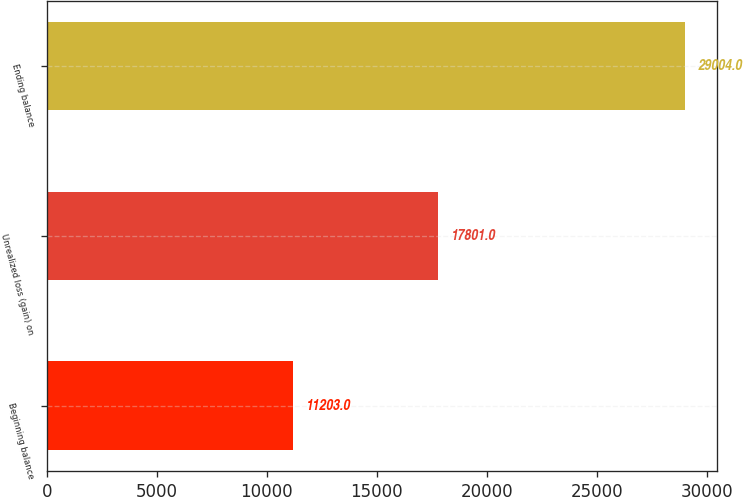Convert chart. <chart><loc_0><loc_0><loc_500><loc_500><bar_chart><fcel>Beginning balance<fcel>Unrealized loss (gain) on<fcel>Ending balance<nl><fcel>11203<fcel>17801<fcel>29004<nl></chart> 